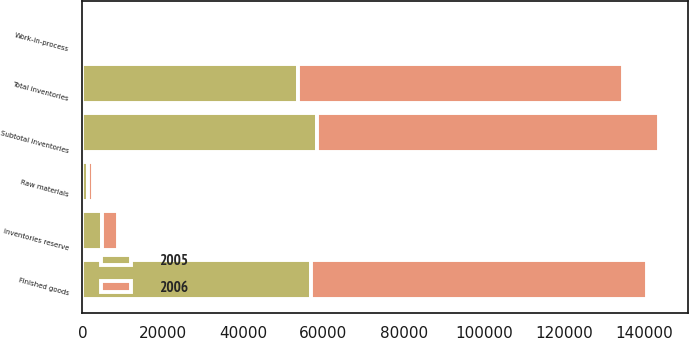<chart> <loc_0><loc_0><loc_500><loc_500><stacked_bar_chart><ecel><fcel>Finished goods<fcel>Raw materials<fcel>Work-in-process<fcel>Subtotal inventories<fcel>Inventories reserve<fcel>Total inventories<nl><fcel>2006<fcel>83618<fcel>1321<fcel>133<fcel>85072<fcel>4041<fcel>81031<nl><fcel>2005<fcel>57020<fcel>1379<fcel>95<fcel>58494<fcel>4887<fcel>53607<nl></chart> 